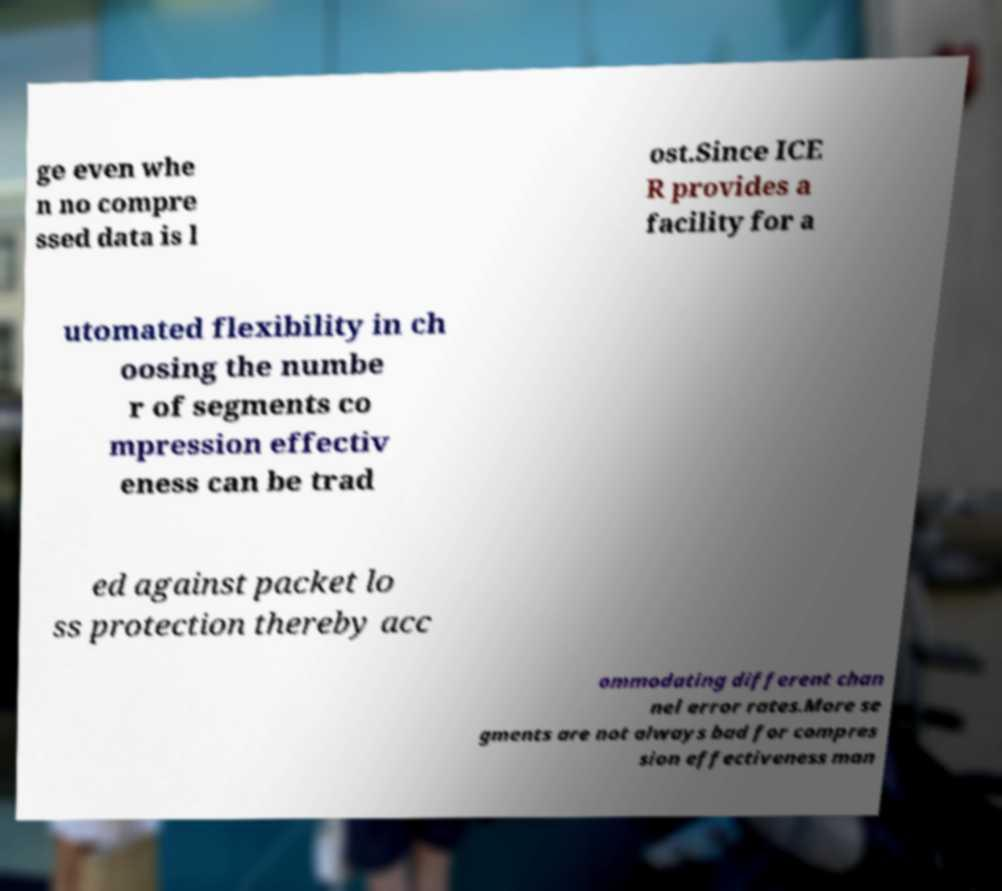Could you extract and type out the text from this image? ge even whe n no compre ssed data is l ost.Since ICE R provides a facility for a utomated flexibility in ch oosing the numbe r of segments co mpression effectiv eness can be trad ed against packet lo ss protection thereby acc ommodating different chan nel error rates.More se gments are not always bad for compres sion effectiveness man 